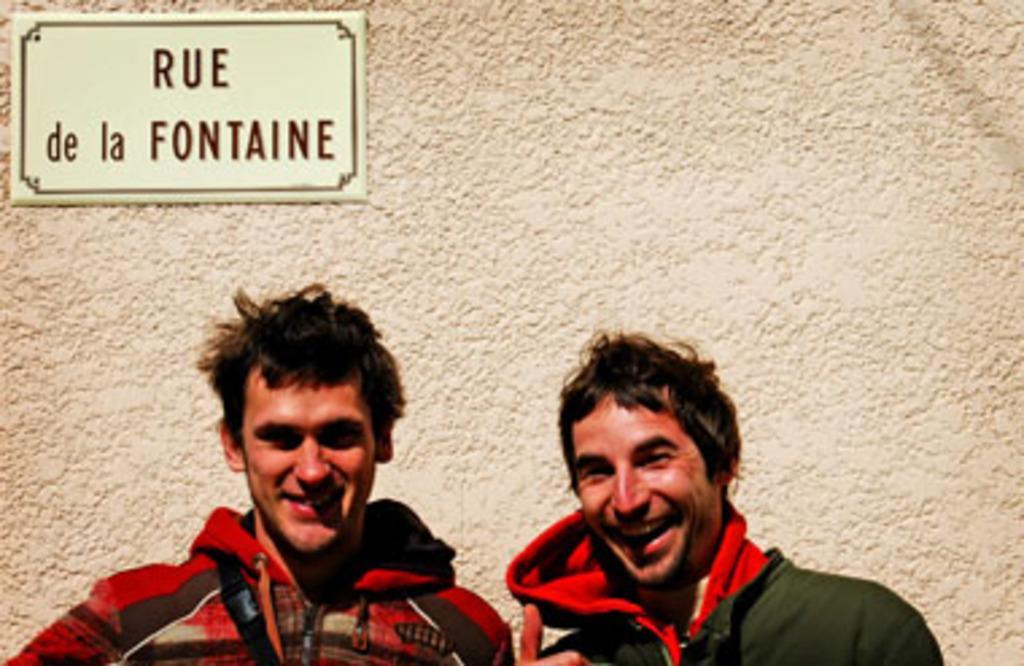Describe this image in one or two sentences. In this image I can see two persons, the person at right wearing green and red color dress and the person at left wearing black and red color dress. Background I can see a board attached to the wall and the wall is in white color. 